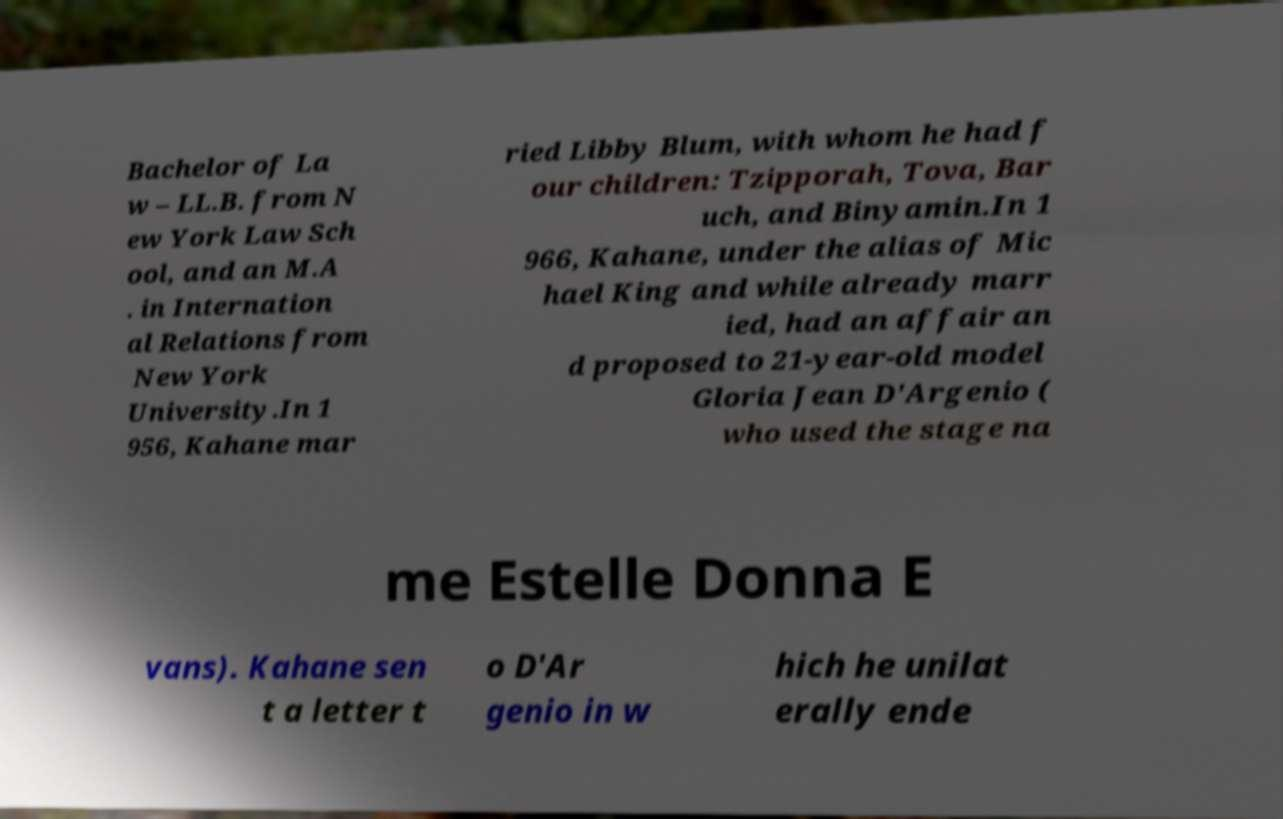Please identify and transcribe the text found in this image. Bachelor of La w – LL.B. from N ew York Law Sch ool, and an M.A . in Internation al Relations from New York University.In 1 956, Kahane mar ried Libby Blum, with whom he had f our children: Tzipporah, Tova, Bar uch, and Binyamin.In 1 966, Kahane, under the alias of Mic hael King and while already marr ied, had an affair an d proposed to 21-year-old model Gloria Jean D'Argenio ( who used the stage na me Estelle Donna E vans). Kahane sen t a letter t o D'Ar genio in w hich he unilat erally ende 